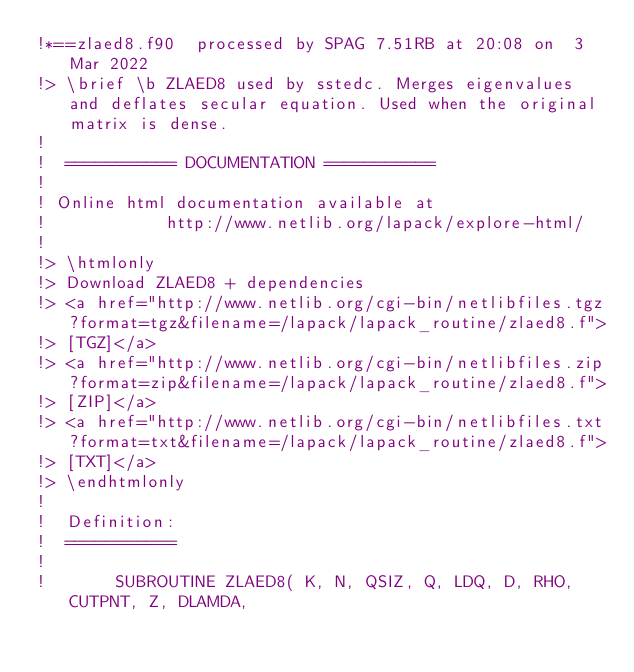<code> <loc_0><loc_0><loc_500><loc_500><_FORTRAN_>!*==zlaed8.f90  processed by SPAG 7.51RB at 20:08 on  3 Mar 2022
!> \brief \b ZLAED8 used by sstedc. Merges eigenvalues and deflates secular equation. Used when the original matrix is dense.
!
!  =========== DOCUMENTATION ===========
!
! Online html documentation available at
!            http://www.netlib.org/lapack/explore-html/
!
!> \htmlonly
!> Download ZLAED8 + dependencies
!> <a href="http://www.netlib.org/cgi-bin/netlibfiles.tgz?format=tgz&filename=/lapack/lapack_routine/zlaed8.f">
!> [TGZ]</a>
!> <a href="http://www.netlib.org/cgi-bin/netlibfiles.zip?format=zip&filename=/lapack/lapack_routine/zlaed8.f">
!> [ZIP]</a>
!> <a href="http://www.netlib.org/cgi-bin/netlibfiles.txt?format=txt&filename=/lapack/lapack_routine/zlaed8.f">
!> [TXT]</a>
!> \endhtmlonly
!
!  Definition:
!  ===========
!
!       SUBROUTINE ZLAED8( K, N, QSIZ, Q, LDQ, D, RHO, CUTPNT, Z, DLAMDA,</code> 